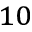Convert formula to latex. <formula><loc_0><loc_0><loc_500><loc_500>^ { 1 0 }</formula> 